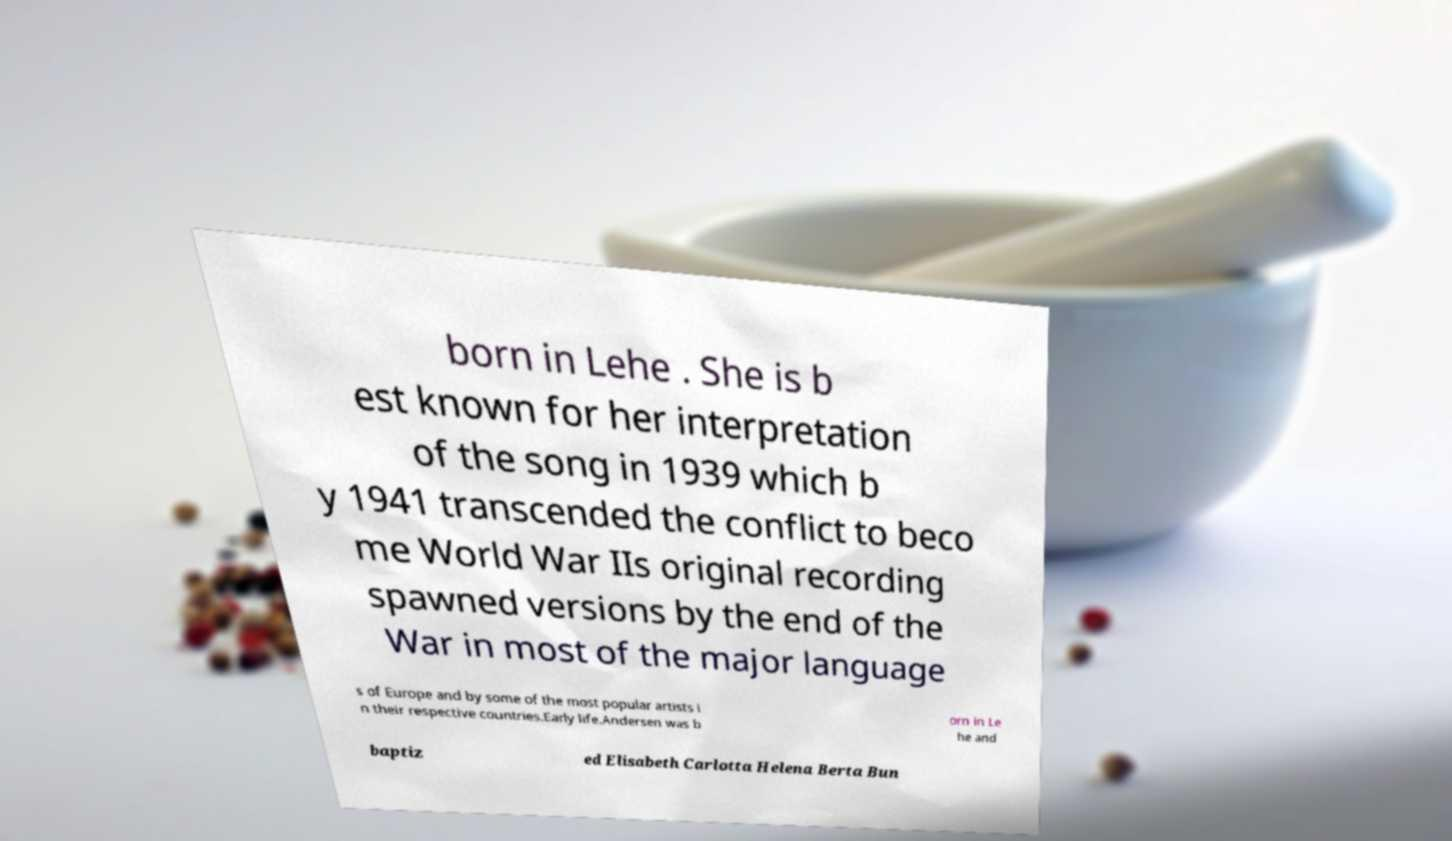Could you extract and type out the text from this image? born in Lehe . She is b est known for her interpretation of the song in 1939 which b y 1941 transcended the conflict to beco me World War IIs original recording spawned versions by the end of the War in most of the major language s of Europe and by some of the most popular artists i n their respective countries.Early life.Andersen was b orn in Le he and baptiz ed Elisabeth Carlotta Helena Berta Bun 